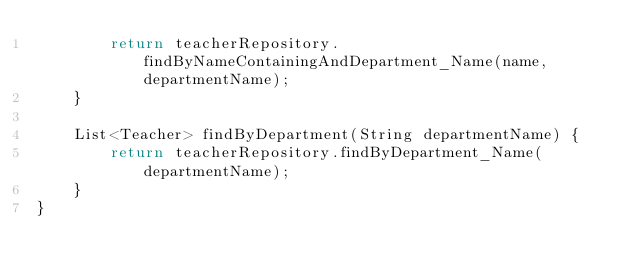Convert code to text. <code><loc_0><loc_0><loc_500><loc_500><_Java_>        return teacherRepository.findByNameContainingAndDepartment_Name(name, departmentName);
    }

    List<Teacher> findByDepartment(String departmentName) {
        return teacherRepository.findByDepartment_Name(departmentName);
    }
}
</code> 